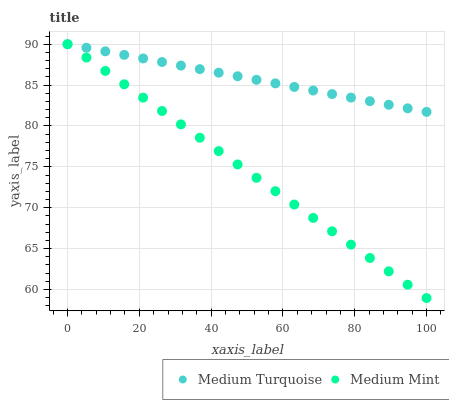Does Medium Mint have the minimum area under the curve?
Answer yes or no. Yes. Does Medium Turquoise have the maximum area under the curve?
Answer yes or no. Yes. Does Medium Turquoise have the minimum area under the curve?
Answer yes or no. No. Is Medium Mint the smoothest?
Answer yes or no. Yes. Is Medium Turquoise the roughest?
Answer yes or no. Yes. Is Medium Turquoise the smoothest?
Answer yes or no. No. Does Medium Mint have the lowest value?
Answer yes or no. Yes. Does Medium Turquoise have the lowest value?
Answer yes or no. No. Does Medium Turquoise have the highest value?
Answer yes or no. Yes. Does Medium Mint intersect Medium Turquoise?
Answer yes or no. Yes. Is Medium Mint less than Medium Turquoise?
Answer yes or no. No. Is Medium Mint greater than Medium Turquoise?
Answer yes or no. No. 